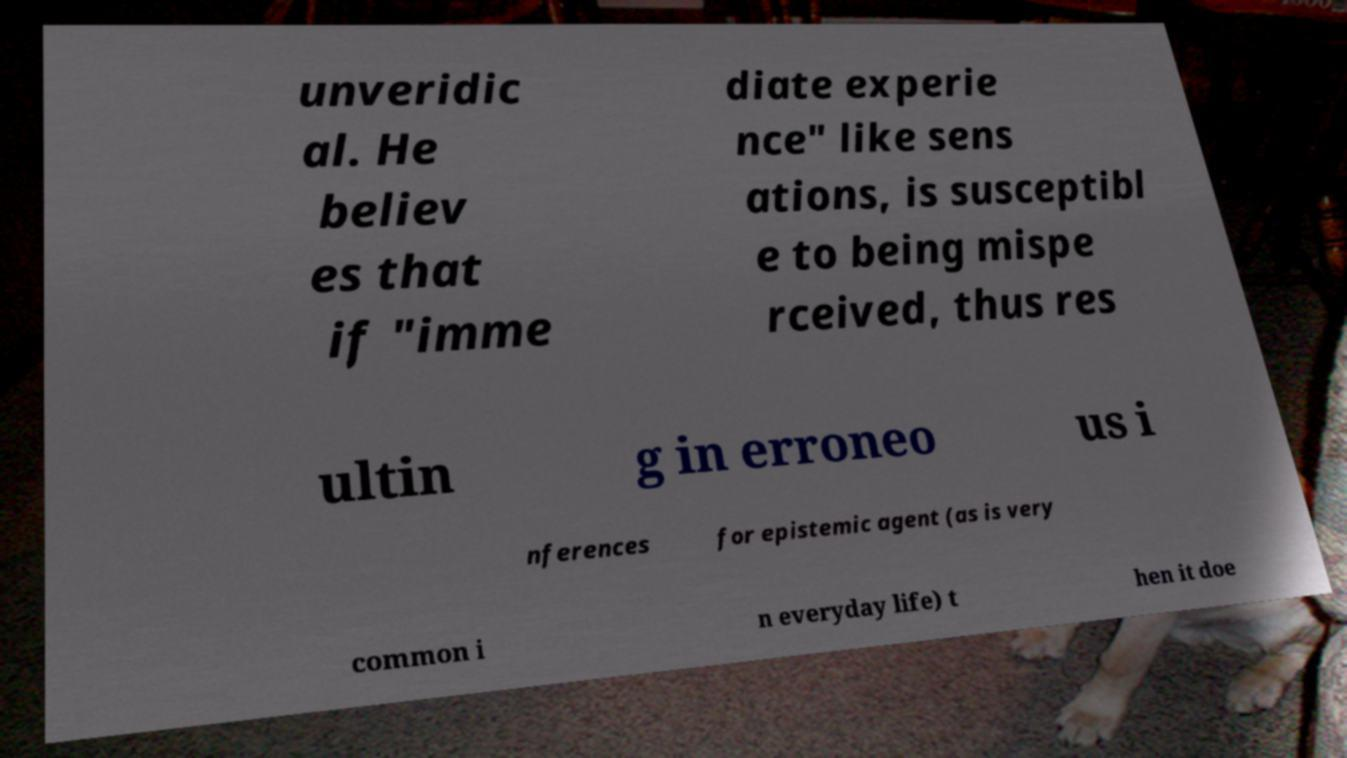There's text embedded in this image that I need extracted. Can you transcribe it verbatim? unveridic al. He believ es that if "imme diate experie nce" like sens ations, is susceptibl e to being mispe rceived, thus res ultin g in erroneo us i nferences for epistemic agent (as is very common i n everyday life) t hen it doe 